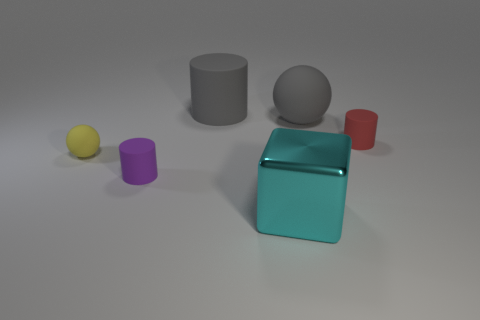Add 4 yellow objects. How many objects exist? 10 Subtract all cubes. How many objects are left? 5 Add 2 purple rubber objects. How many purple rubber objects are left? 3 Add 6 spheres. How many spheres exist? 8 Subtract 0 gray blocks. How many objects are left? 6 Subtract all small red rubber things. Subtract all small purple rubber cylinders. How many objects are left? 4 